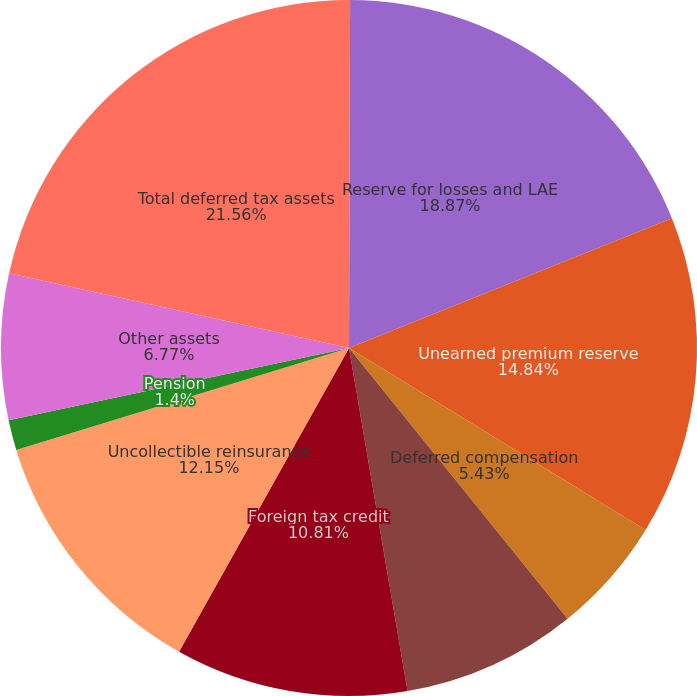Convert chart. <chart><loc_0><loc_0><loc_500><loc_500><pie_chart><fcel>(Dollars in thousands)<fcel>Reserve for losses and LAE<fcel>Unearned premium reserve<fcel>Deferred compensation<fcel>AMT Credits<fcel>Foreign tax credit<fcel>Uncollectible reinsurance<fcel>Pension<fcel>Other assets<fcel>Total deferred tax assets<nl><fcel>0.05%<fcel>18.87%<fcel>14.84%<fcel>5.43%<fcel>8.12%<fcel>10.81%<fcel>12.15%<fcel>1.4%<fcel>6.77%<fcel>21.56%<nl></chart> 